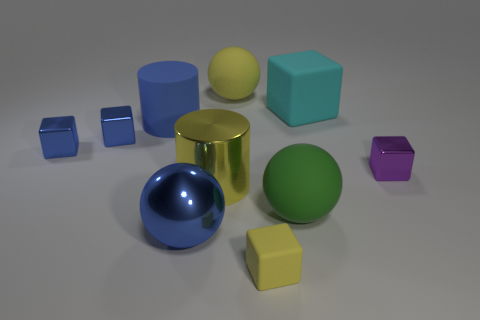What number of other things are there of the same shape as the large blue matte object?
Provide a succinct answer. 1. Does the large yellow object behind the big cyan rubber object have the same material as the blue sphere?
Provide a short and direct response. No. Is the number of large yellow balls that are to the left of the yellow rubber ball the same as the number of big cylinders that are to the left of the large blue ball?
Provide a short and direct response. No. What size is the yellow object that is on the right side of the yellow sphere?
Offer a very short reply. Small. Are there any large brown cylinders made of the same material as the blue cylinder?
Keep it short and to the point. No. There is a big cylinder that is behind the tiny purple thing; is its color the same as the metallic sphere?
Your answer should be compact. Yes. Are there an equal number of tiny yellow rubber blocks that are in front of the tiny yellow thing and matte blocks?
Offer a terse response. No. Are there any shiny things that have the same color as the large cube?
Your answer should be compact. No. Do the matte cylinder and the blue shiny ball have the same size?
Your answer should be compact. Yes. What size is the yellow thing behind the big matte object left of the yellow sphere?
Keep it short and to the point. Large. 